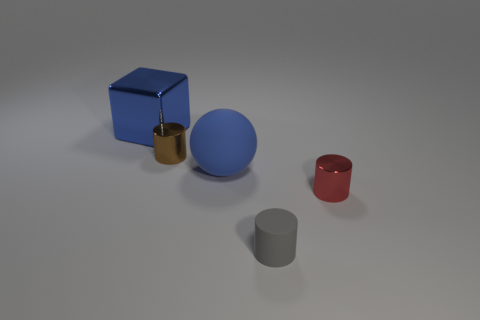Subtract all metal cylinders. How many cylinders are left? 1 Add 5 big blue rubber spheres. How many objects exist? 10 Subtract all brown cylinders. How many cylinders are left? 2 Subtract all cubes. How many objects are left? 4 Add 1 tiny red cylinders. How many tiny red cylinders are left? 2 Add 3 big cyan shiny cylinders. How many big cyan shiny cylinders exist? 3 Subtract 0 green cubes. How many objects are left? 5 Subtract 3 cylinders. How many cylinders are left? 0 Subtract all red spheres. Subtract all green cylinders. How many spheres are left? 1 Subtract all blue balls. Subtract all brown balls. How many objects are left? 4 